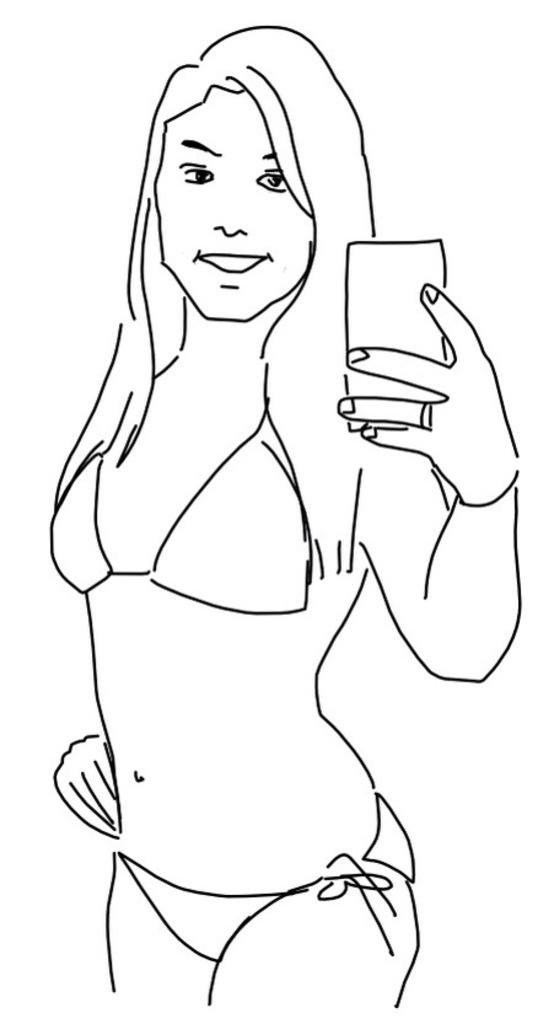What is depicted in the image? There is a sketch of a woman in the image. What is the woman holding in the sketch? The woman is holding an object that resembles a cellphone. What type of rake is the woman using in the image? There is no rake present in the image; it features a sketch of a woman holding an object that resembles a cellphone. What is the texture of the jam on the woman's face in the image? There is no jam present on the woman's face in the image; she is holding an object that resembles a cellphone. 